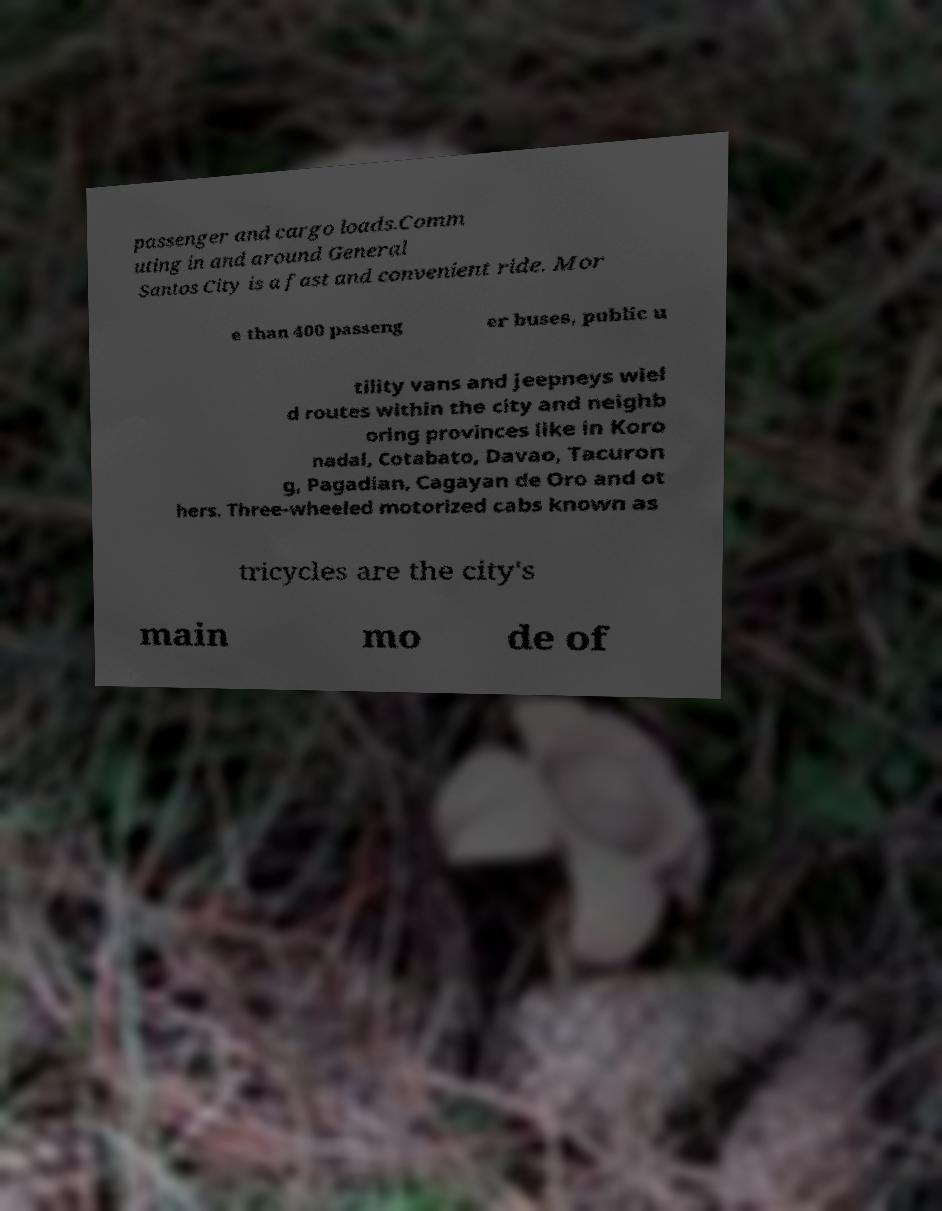Please identify and transcribe the text found in this image. passenger and cargo loads.Comm uting in and around General Santos City is a fast and convenient ride. Mor e than 400 passeng er buses, public u tility vans and jeepneys wiel d routes within the city and neighb oring provinces like in Koro nadal, Cotabato, Davao, Tacuron g, Pagadian, Cagayan de Oro and ot hers. Three-wheeled motorized cabs known as tricycles are the city's main mo de of 